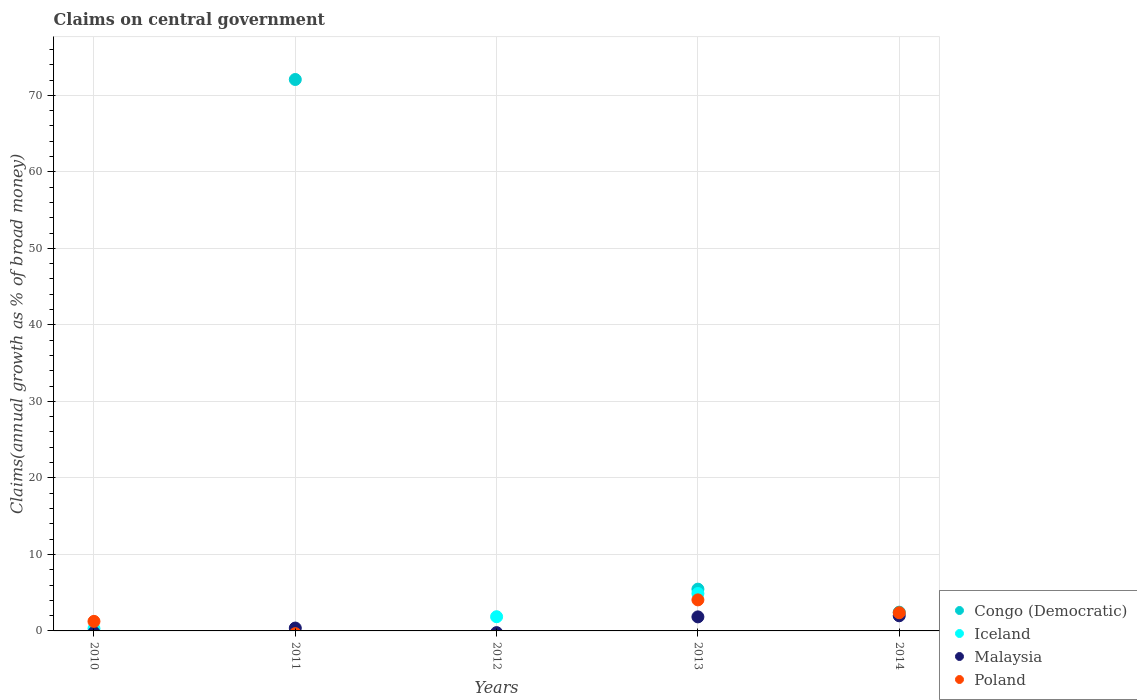What is the percentage of broad money claimed on centeral government in Iceland in 2012?
Offer a terse response. 1.86. Across all years, what is the maximum percentage of broad money claimed on centeral government in Congo (Democratic)?
Ensure brevity in your answer.  72.07. Across all years, what is the minimum percentage of broad money claimed on centeral government in Congo (Democratic)?
Make the answer very short. 0. In which year was the percentage of broad money claimed on centeral government in Iceland maximum?
Your answer should be compact. 2013. What is the total percentage of broad money claimed on centeral government in Congo (Democratic) in the graph?
Offer a terse response. 79.98. What is the difference between the percentage of broad money claimed on centeral government in Poland in 2010 and that in 2013?
Your response must be concise. -2.81. What is the difference between the percentage of broad money claimed on centeral government in Congo (Democratic) in 2011 and the percentage of broad money claimed on centeral government in Malaysia in 2010?
Offer a very short reply. 72.07. What is the average percentage of broad money claimed on centeral government in Congo (Democratic) per year?
Keep it short and to the point. 16. In the year 2013, what is the difference between the percentage of broad money claimed on centeral government in Congo (Democratic) and percentage of broad money claimed on centeral government in Poland?
Provide a short and direct response. 1.4. In how many years, is the percentage of broad money claimed on centeral government in Malaysia greater than 18 %?
Ensure brevity in your answer.  0. Is the percentage of broad money claimed on centeral government in Congo (Democratic) in 2013 less than that in 2014?
Provide a short and direct response. No. What is the difference between the highest and the second highest percentage of broad money claimed on centeral government in Malaysia?
Provide a short and direct response. 0.14. What is the difference between the highest and the lowest percentage of broad money claimed on centeral government in Congo (Democratic)?
Offer a terse response. 72.07. In how many years, is the percentage of broad money claimed on centeral government in Congo (Democratic) greater than the average percentage of broad money claimed on centeral government in Congo (Democratic) taken over all years?
Make the answer very short. 1. Is it the case that in every year, the sum of the percentage of broad money claimed on centeral government in Malaysia and percentage of broad money claimed on centeral government in Iceland  is greater than the percentage of broad money claimed on centeral government in Poland?
Your answer should be very brief. No. Is the percentage of broad money claimed on centeral government in Malaysia strictly greater than the percentage of broad money claimed on centeral government in Iceland over the years?
Ensure brevity in your answer.  No. How many dotlines are there?
Make the answer very short. 4. Are the values on the major ticks of Y-axis written in scientific E-notation?
Your answer should be compact. No. Does the graph contain any zero values?
Give a very brief answer. Yes. How many legend labels are there?
Provide a short and direct response. 4. What is the title of the graph?
Your response must be concise. Claims on central government. What is the label or title of the Y-axis?
Offer a terse response. Claims(annual growth as % of broad money). What is the Claims(annual growth as % of broad money) in Iceland in 2010?
Provide a succinct answer. 0.3. What is the Claims(annual growth as % of broad money) in Poland in 2010?
Offer a terse response. 1.25. What is the Claims(annual growth as % of broad money) of Congo (Democratic) in 2011?
Offer a very short reply. 72.07. What is the Claims(annual growth as % of broad money) in Iceland in 2011?
Offer a terse response. 0. What is the Claims(annual growth as % of broad money) of Malaysia in 2011?
Offer a terse response. 0.37. What is the Claims(annual growth as % of broad money) in Iceland in 2012?
Keep it short and to the point. 1.86. What is the Claims(annual growth as % of broad money) in Poland in 2012?
Offer a terse response. 0. What is the Claims(annual growth as % of broad money) in Congo (Democratic) in 2013?
Your answer should be compact. 5.46. What is the Claims(annual growth as % of broad money) of Iceland in 2013?
Offer a very short reply. 4.89. What is the Claims(annual growth as % of broad money) of Malaysia in 2013?
Make the answer very short. 1.84. What is the Claims(annual growth as % of broad money) in Poland in 2013?
Keep it short and to the point. 4.06. What is the Claims(annual growth as % of broad money) of Congo (Democratic) in 2014?
Your answer should be compact. 2.45. What is the Claims(annual growth as % of broad money) of Malaysia in 2014?
Your answer should be compact. 1.98. What is the Claims(annual growth as % of broad money) of Poland in 2014?
Your answer should be very brief. 2.38. Across all years, what is the maximum Claims(annual growth as % of broad money) of Congo (Democratic)?
Provide a succinct answer. 72.07. Across all years, what is the maximum Claims(annual growth as % of broad money) of Iceland?
Ensure brevity in your answer.  4.89. Across all years, what is the maximum Claims(annual growth as % of broad money) of Malaysia?
Give a very brief answer. 1.98. Across all years, what is the maximum Claims(annual growth as % of broad money) of Poland?
Your answer should be very brief. 4.06. What is the total Claims(annual growth as % of broad money) of Congo (Democratic) in the graph?
Provide a short and direct response. 79.98. What is the total Claims(annual growth as % of broad money) in Iceland in the graph?
Your answer should be compact. 7.05. What is the total Claims(annual growth as % of broad money) of Malaysia in the graph?
Offer a very short reply. 4.19. What is the total Claims(annual growth as % of broad money) of Poland in the graph?
Your answer should be compact. 7.68. What is the difference between the Claims(annual growth as % of broad money) in Iceland in 2010 and that in 2012?
Keep it short and to the point. -1.56. What is the difference between the Claims(annual growth as % of broad money) in Iceland in 2010 and that in 2013?
Your answer should be compact. -4.59. What is the difference between the Claims(annual growth as % of broad money) of Poland in 2010 and that in 2013?
Offer a very short reply. -2.81. What is the difference between the Claims(annual growth as % of broad money) in Poland in 2010 and that in 2014?
Make the answer very short. -1.13. What is the difference between the Claims(annual growth as % of broad money) in Congo (Democratic) in 2011 and that in 2013?
Give a very brief answer. 66.61. What is the difference between the Claims(annual growth as % of broad money) in Malaysia in 2011 and that in 2013?
Make the answer very short. -1.46. What is the difference between the Claims(annual growth as % of broad money) in Congo (Democratic) in 2011 and that in 2014?
Offer a terse response. 69.62. What is the difference between the Claims(annual growth as % of broad money) in Malaysia in 2011 and that in 2014?
Offer a very short reply. -1.6. What is the difference between the Claims(annual growth as % of broad money) of Iceland in 2012 and that in 2013?
Your answer should be very brief. -3.03. What is the difference between the Claims(annual growth as % of broad money) of Congo (Democratic) in 2013 and that in 2014?
Keep it short and to the point. 3.01. What is the difference between the Claims(annual growth as % of broad money) in Malaysia in 2013 and that in 2014?
Ensure brevity in your answer.  -0.14. What is the difference between the Claims(annual growth as % of broad money) in Poland in 2013 and that in 2014?
Ensure brevity in your answer.  1.68. What is the difference between the Claims(annual growth as % of broad money) in Iceland in 2010 and the Claims(annual growth as % of broad money) in Malaysia in 2011?
Keep it short and to the point. -0.07. What is the difference between the Claims(annual growth as % of broad money) in Iceland in 2010 and the Claims(annual growth as % of broad money) in Malaysia in 2013?
Offer a terse response. -1.53. What is the difference between the Claims(annual growth as % of broad money) in Iceland in 2010 and the Claims(annual growth as % of broad money) in Poland in 2013?
Your answer should be very brief. -3.76. What is the difference between the Claims(annual growth as % of broad money) in Iceland in 2010 and the Claims(annual growth as % of broad money) in Malaysia in 2014?
Ensure brevity in your answer.  -1.68. What is the difference between the Claims(annual growth as % of broad money) of Iceland in 2010 and the Claims(annual growth as % of broad money) of Poland in 2014?
Offer a very short reply. -2.08. What is the difference between the Claims(annual growth as % of broad money) in Congo (Democratic) in 2011 and the Claims(annual growth as % of broad money) in Iceland in 2012?
Offer a very short reply. 70.21. What is the difference between the Claims(annual growth as % of broad money) of Congo (Democratic) in 2011 and the Claims(annual growth as % of broad money) of Iceland in 2013?
Ensure brevity in your answer.  67.18. What is the difference between the Claims(annual growth as % of broad money) of Congo (Democratic) in 2011 and the Claims(annual growth as % of broad money) of Malaysia in 2013?
Ensure brevity in your answer.  70.23. What is the difference between the Claims(annual growth as % of broad money) in Congo (Democratic) in 2011 and the Claims(annual growth as % of broad money) in Poland in 2013?
Offer a very short reply. 68.01. What is the difference between the Claims(annual growth as % of broad money) of Malaysia in 2011 and the Claims(annual growth as % of broad money) of Poland in 2013?
Provide a short and direct response. -3.68. What is the difference between the Claims(annual growth as % of broad money) of Congo (Democratic) in 2011 and the Claims(annual growth as % of broad money) of Malaysia in 2014?
Provide a succinct answer. 70.09. What is the difference between the Claims(annual growth as % of broad money) in Congo (Democratic) in 2011 and the Claims(annual growth as % of broad money) in Poland in 2014?
Your response must be concise. 69.69. What is the difference between the Claims(annual growth as % of broad money) of Malaysia in 2011 and the Claims(annual growth as % of broad money) of Poland in 2014?
Ensure brevity in your answer.  -2. What is the difference between the Claims(annual growth as % of broad money) in Iceland in 2012 and the Claims(annual growth as % of broad money) in Malaysia in 2013?
Ensure brevity in your answer.  0.02. What is the difference between the Claims(annual growth as % of broad money) in Iceland in 2012 and the Claims(annual growth as % of broad money) in Poland in 2013?
Offer a terse response. -2.2. What is the difference between the Claims(annual growth as % of broad money) of Iceland in 2012 and the Claims(annual growth as % of broad money) of Malaysia in 2014?
Offer a terse response. -0.12. What is the difference between the Claims(annual growth as % of broad money) in Iceland in 2012 and the Claims(annual growth as % of broad money) in Poland in 2014?
Offer a terse response. -0.52. What is the difference between the Claims(annual growth as % of broad money) in Congo (Democratic) in 2013 and the Claims(annual growth as % of broad money) in Malaysia in 2014?
Offer a terse response. 3.48. What is the difference between the Claims(annual growth as % of broad money) in Congo (Democratic) in 2013 and the Claims(annual growth as % of broad money) in Poland in 2014?
Make the answer very short. 3.08. What is the difference between the Claims(annual growth as % of broad money) in Iceland in 2013 and the Claims(annual growth as % of broad money) in Malaysia in 2014?
Provide a succinct answer. 2.91. What is the difference between the Claims(annual growth as % of broad money) of Iceland in 2013 and the Claims(annual growth as % of broad money) of Poland in 2014?
Provide a short and direct response. 2.51. What is the difference between the Claims(annual growth as % of broad money) in Malaysia in 2013 and the Claims(annual growth as % of broad money) in Poland in 2014?
Offer a very short reply. -0.54. What is the average Claims(annual growth as % of broad money) of Congo (Democratic) per year?
Ensure brevity in your answer.  16. What is the average Claims(annual growth as % of broad money) in Iceland per year?
Your answer should be compact. 1.41. What is the average Claims(annual growth as % of broad money) of Malaysia per year?
Provide a succinct answer. 0.84. What is the average Claims(annual growth as % of broad money) in Poland per year?
Your answer should be very brief. 1.54. In the year 2010, what is the difference between the Claims(annual growth as % of broad money) in Iceland and Claims(annual growth as % of broad money) in Poland?
Your answer should be very brief. -0.95. In the year 2011, what is the difference between the Claims(annual growth as % of broad money) in Congo (Democratic) and Claims(annual growth as % of broad money) in Malaysia?
Give a very brief answer. 71.69. In the year 2013, what is the difference between the Claims(annual growth as % of broad money) of Congo (Democratic) and Claims(annual growth as % of broad money) of Iceland?
Make the answer very short. 0.57. In the year 2013, what is the difference between the Claims(annual growth as % of broad money) of Congo (Democratic) and Claims(annual growth as % of broad money) of Malaysia?
Make the answer very short. 3.62. In the year 2013, what is the difference between the Claims(annual growth as % of broad money) in Congo (Democratic) and Claims(annual growth as % of broad money) in Poland?
Your answer should be very brief. 1.4. In the year 2013, what is the difference between the Claims(annual growth as % of broad money) of Iceland and Claims(annual growth as % of broad money) of Malaysia?
Keep it short and to the point. 3.05. In the year 2013, what is the difference between the Claims(annual growth as % of broad money) in Iceland and Claims(annual growth as % of broad money) in Poland?
Keep it short and to the point. 0.83. In the year 2013, what is the difference between the Claims(annual growth as % of broad money) in Malaysia and Claims(annual growth as % of broad money) in Poland?
Make the answer very short. -2.22. In the year 2014, what is the difference between the Claims(annual growth as % of broad money) in Congo (Democratic) and Claims(annual growth as % of broad money) in Malaysia?
Provide a short and direct response. 0.47. In the year 2014, what is the difference between the Claims(annual growth as % of broad money) of Congo (Democratic) and Claims(annual growth as % of broad money) of Poland?
Ensure brevity in your answer.  0.07. In the year 2014, what is the difference between the Claims(annual growth as % of broad money) of Malaysia and Claims(annual growth as % of broad money) of Poland?
Provide a succinct answer. -0.4. What is the ratio of the Claims(annual growth as % of broad money) of Iceland in 2010 to that in 2012?
Your response must be concise. 0.16. What is the ratio of the Claims(annual growth as % of broad money) of Iceland in 2010 to that in 2013?
Give a very brief answer. 0.06. What is the ratio of the Claims(annual growth as % of broad money) of Poland in 2010 to that in 2013?
Give a very brief answer. 0.31. What is the ratio of the Claims(annual growth as % of broad money) in Poland in 2010 to that in 2014?
Give a very brief answer. 0.52. What is the ratio of the Claims(annual growth as % of broad money) in Congo (Democratic) in 2011 to that in 2013?
Your answer should be compact. 13.2. What is the ratio of the Claims(annual growth as % of broad money) in Malaysia in 2011 to that in 2013?
Your answer should be very brief. 0.2. What is the ratio of the Claims(annual growth as % of broad money) of Congo (Democratic) in 2011 to that in 2014?
Provide a short and direct response. 29.4. What is the ratio of the Claims(annual growth as % of broad money) in Malaysia in 2011 to that in 2014?
Offer a very short reply. 0.19. What is the ratio of the Claims(annual growth as % of broad money) of Iceland in 2012 to that in 2013?
Ensure brevity in your answer.  0.38. What is the ratio of the Claims(annual growth as % of broad money) in Congo (Democratic) in 2013 to that in 2014?
Your answer should be very brief. 2.23. What is the ratio of the Claims(annual growth as % of broad money) in Malaysia in 2013 to that in 2014?
Your answer should be compact. 0.93. What is the ratio of the Claims(annual growth as % of broad money) in Poland in 2013 to that in 2014?
Give a very brief answer. 1.71. What is the difference between the highest and the second highest Claims(annual growth as % of broad money) of Congo (Democratic)?
Provide a succinct answer. 66.61. What is the difference between the highest and the second highest Claims(annual growth as % of broad money) in Iceland?
Your answer should be compact. 3.03. What is the difference between the highest and the second highest Claims(annual growth as % of broad money) in Malaysia?
Your answer should be compact. 0.14. What is the difference between the highest and the second highest Claims(annual growth as % of broad money) of Poland?
Your answer should be very brief. 1.68. What is the difference between the highest and the lowest Claims(annual growth as % of broad money) in Congo (Democratic)?
Your response must be concise. 72.07. What is the difference between the highest and the lowest Claims(annual growth as % of broad money) in Iceland?
Give a very brief answer. 4.89. What is the difference between the highest and the lowest Claims(annual growth as % of broad money) in Malaysia?
Ensure brevity in your answer.  1.98. What is the difference between the highest and the lowest Claims(annual growth as % of broad money) in Poland?
Keep it short and to the point. 4.06. 